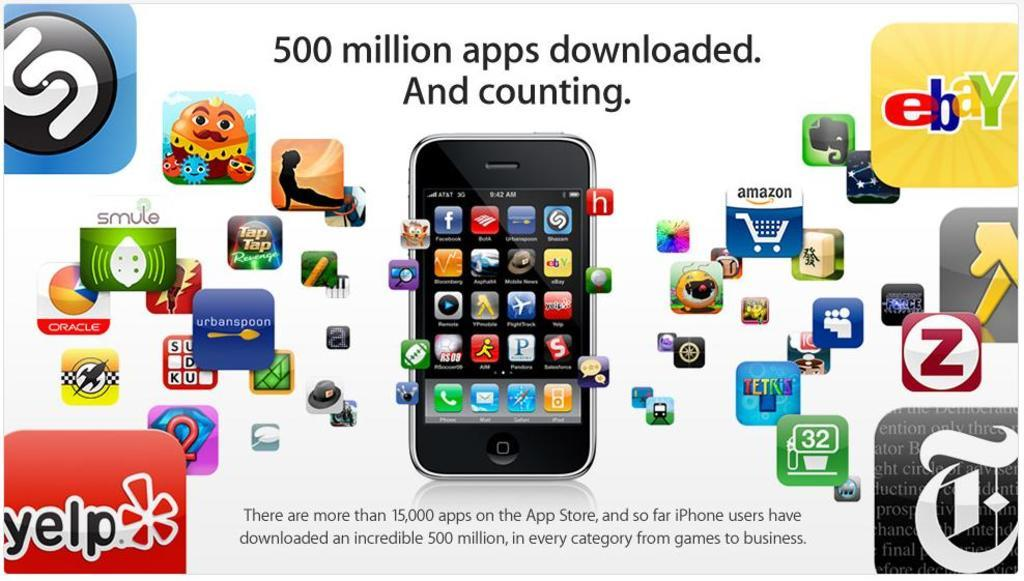Provide a one-sentence caption for the provided image. An ad with may logos displayed has ebay in one corner and Yelp in another. 